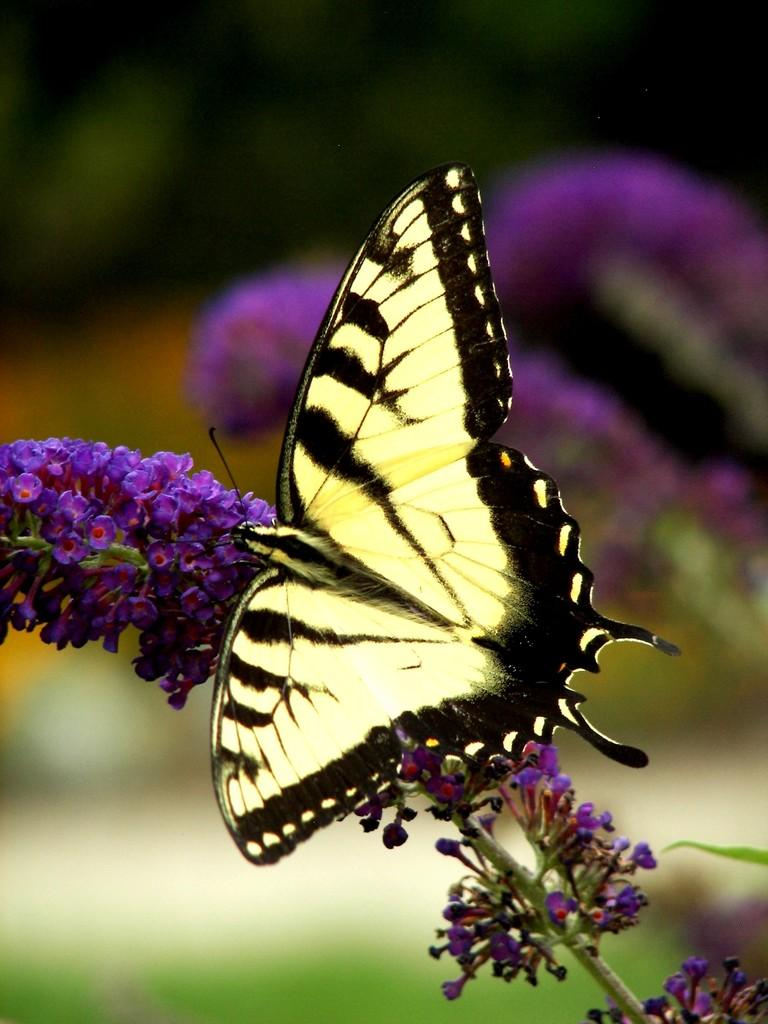What is the main subject of the image? There is a butterfly in the image. Where is the butterfly located in the image? The butterfly is sitting on purple flowers. Can you describe the background of the image? The background of the image appears blurry. How many people are in the group that went on the trip in the image? There is no group or trip present in the image; it features a butterfly sitting on purple flowers. What type of wood can be seen in the image? There is no wood present in the image. 